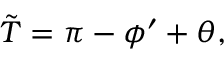Convert formula to latex. <formula><loc_0><loc_0><loc_500><loc_500>\tilde { T } = \pi - \phi ^ { \prime } + \theta ,</formula> 